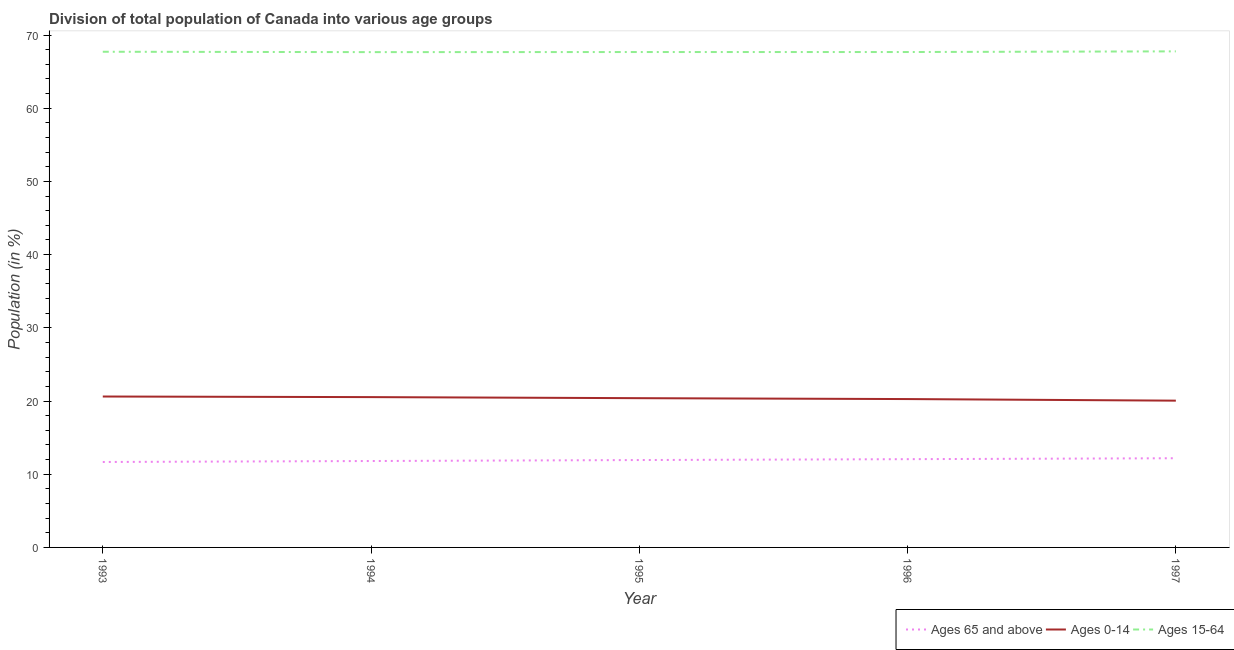How many different coloured lines are there?
Offer a very short reply. 3. Does the line corresponding to percentage of population within the age-group 15-64 intersect with the line corresponding to percentage of population within the age-group of 65 and above?
Ensure brevity in your answer.  No. What is the percentage of population within the age-group 15-64 in 1993?
Make the answer very short. 67.71. Across all years, what is the maximum percentage of population within the age-group of 65 and above?
Your answer should be very brief. 12.18. Across all years, what is the minimum percentage of population within the age-group of 65 and above?
Give a very brief answer. 11.67. In which year was the percentage of population within the age-group of 65 and above maximum?
Keep it short and to the point. 1997. What is the total percentage of population within the age-group 15-64 in the graph?
Your answer should be very brief. 338.49. What is the difference between the percentage of population within the age-group 0-14 in 1994 and that in 1995?
Your answer should be compact. 0.15. What is the difference between the percentage of population within the age-group 15-64 in 1997 and the percentage of population within the age-group 0-14 in 1993?
Ensure brevity in your answer.  47.15. What is the average percentage of population within the age-group 15-64 per year?
Give a very brief answer. 67.7. In the year 1994, what is the difference between the percentage of population within the age-group 15-64 and percentage of population within the age-group of 65 and above?
Make the answer very short. 55.86. What is the ratio of the percentage of population within the age-group 0-14 in 1993 to that in 1994?
Provide a succinct answer. 1. Is the percentage of population within the age-group 0-14 in 1995 less than that in 1996?
Offer a terse response. No. Is the difference between the percentage of population within the age-group 0-14 in 1994 and 1996 greater than the difference between the percentage of population within the age-group 15-64 in 1994 and 1996?
Give a very brief answer. Yes. What is the difference between the highest and the second highest percentage of population within the age-group 15-64?
Offer a very short reply. 0.05. What is the difference between the highest and the lowest percentage of population within the age-group of 65 and above?
Your answer should be very brief. 0.51. In how many years, is the percentage of population within the age-group 15-64 greater than the average percentage of population within the age-group 15-64 taken over all years?
Offer a very short reply. 2. Is the sum of the percentage of population within the age-group 0-14 in 1993 and 1994 greater than the maximum percentage of population within the age-group of 65 and above across all years?
Give a very brief answer. Yes. Is it the case that in every year, the sum of the percentage of population within the age-group of 65 and above and percentage of population within the age-group 0-14 is greater than the percentage of population within the age-group 15-64?
Keep it short and to the point. No. Does the percentage of population within the age-group 0-14 monotonically increase over the years?
Offer a very short reply. No. What is the difference between two consecutive major ticks on the Y-axis?
Make the answer very short. 10. Are the values on the major ticks of Y-axis written in scientific E-notation?
Make the answer very short. No. Does the graph contain any zero values?
Give a very brief answer. No. What is the title of the graph?
Your answer should be very brief. Division of total population of Canada into various age groups
. Does "Communicable diseases" appear as one of the legend labels in the graph?
Provide a short and direct response. No. What is the Population (in %) of Ages 65 and above in 1993?
Your answer should be compact. 11.67. What is the Population (in %) in Ages 0-14 in 1993?
Make the answer very short. 20.62. What is the Population (in %) in Ages 15-64 in 1993?
Your answer should be compact. 67.71. What is the Population (in %) of Ages 65 and above in 1994?
Your response must be concise. 11.8. What is the Population (in %) of Ages 0-14 in 1994?
Make the answer very short. 20.53. What is the Population (in %) of Ages 15-64 in 1994?
Keep it short and to the point. 67.66. What is the Population (in %) in Ages 65 and above in 1995?
Your answer should be very brief. 11.94. What is the Population (in %) in Ages 0-14 in 1995?
Your answer should be very brief. 20.39. What is the Population (in %) in Ages 15-64 in 1995?
Your answer should be very brief. 67.67. What is the Population (in %) of Ages 65 and above in 1996?
Offer a terse response. 12.06. What is the Population (in %) of Ages 0-14 in 1996?
Offer a very short reply. 20.27. What is the Population (in %) in Ages 15-64 in 1996?
Offer a very short reply. 67.67. What is the Population (in %) of Ages 65 and above in 1997?
Your answer should be very brief. 12.18. What is the Population (in %) of Ages 0-14 in 1997?
Make the answer very short. 20.05. What is the Population (in %) in Ages 15-64 in 1997?
Give a very brief answer. 67.77. Across all years, what is the maximum Population (in %) in Ages 65 and above?
Your answer should be very brief. 12.18. Across all years, what is the maximum Population (in %) of Ages 0-14?
Give a very brief answer. 20.62. Across all years, what is the maximum Population (in %) of Ages 15-64?
Provide a succinct answer. 67.77. Across all years, what is the minimum Population (in %) of Ages 65 and above?
Keep it short and to the point. 11.67. Across all years, what is the minimum Population (in %) of Ages 0-14?
Your answer should be very brief. 20.05. Across all years, what is the minimum Population (in %) in Ages 15-64?
Keep it short and to the point. 67.66. What is the total Population (in %) of Ages 65 and above in the graph?
Your answer should be very brief. 59.65. What is the total Population (in %) of Ages 0-14 in the graph?
Provide a short and direct response. 101.86. What is the total Population (in %) of Ages 15-64 in the graph?
Your answer should be very brief. 338.49. What is the difference between the Population (in %) in Ages 65 and above in 1993 and that in 1994?
Your response must be concise. -0.13. What is the difference between the Population (in %) of Ages 0-14 in 1993 and that in 1994?
Offer a terse response. 0.08. What is the difference between the Population (in %) in Ages 15-64 in 1993 and that in 1994?
Offer a terse response. 0.05. What is the difference between the Population (in %) of Ages 65 and above in 1993 and that in 1995?
Ensure brevity in your answer.  -0.27. What is the difference between the Population (in %) in Ages 0-14 in 1993 and that in 1995?
Your answer should be compact. 0.23. What is the difference between the Population (in %) of Ages 15-64 in 1993 and that in 1995?
Offer a terse response. 0.04. What is the difference between the Population (in %) of Ages 65 and above in 1993 and that in 1996?
Your answer should be very brief. -0.39. What is the difference between the Population (in %) in Ages 0-14 in 1993 and that in 1996?
Your response must be concise. 0.35. What is the difference between the Population (in %) in Ages 15-64 in 1993 and that in 1996?
Your answer should be compact. 0.04. What is the difference between the Population (in %) in Ages 65 and above in 1993 and that in 1997?
Ensure brevity in your answer.  -0.51. What is the difference between the Population (in %) of Ages 0-14 in 1993 and that in 1997?
Keep it short and to the point. 0.57. What is the difference between the Population (in %) in Ages 15-64 in 1993 and that in 1997?
Provide a succinct answer. -0.05. What is the difference between the Population (in %) of Ages 65 and above in 1994 and that in 1995?
Ensure brevity in your answer.  -0.13. What is the difference between the Population (in %) of Ages 0-14 in 1994 and that in 1995?
Keep it short and to the point. 0.15. What is the difference between the Population (in %) in Ages 15-64 in 1994 and that in 1995?
Keep it short and to the point. -0.01. What is the difference between the Population (in %) of Ages 65 and above in 1994 and that in 1996?
Make the answer very short. -0.25. What is the difference between the Population (in %) in Ages 0-14 in 1994 and that in 1996?
Your answer should be compact. 0.27. What is the difference between the Population (in %) in Ages 15-64 in 1994 and that in 1996?
Your answer should be compact. -0.01. What is the difference between the Population (in %) of Ages 65 and above in 1994 and that in 1997?
Make the answer very short. -0.38. What is the difference between the Population (in %) of Ages 0-14 in 1994 and that in 1997?
Offer a terse response. 0.48. What is the difference between the Population (in %) of Ages 15-64 in 1994 and that in 1997?
Make the answer very short. -0.1. What is the difference between the Population (in %) of Ages 65 and above in 1995 and that in 1996?
Ensure brevity in your answer.  -0.12. What is the difference between the Population (in %) of Ages 0-14 in 1995 and that in 1996?
Give a very brief answer. 0.12. What is the difference between the Population (in %) of Ages 15-64 in 1995 and that in 1996?
Offer a very short reply. -0. What is the difference between the Population (in %) in Ages 65 and above in 1995 and that in 1997?
Offer a very short reply. -0.25. What is the difference between the Population (in %) in Ages 0-14 in 1995 and that in 1997?
Keep it short and to the point. 0.34. What is the difference between the Population (in %) of Ages 15-64 in 1995 and that in 1997?
Your answer should be compact. -0.09. What is the difference between the Population (in %) in Ages 65 and above in 1996 and that in 1997?
Your answer should be compact. -0.13. What is the difference between the Population (in %) of Ages 0-14 in 1996 and that in 1997?
Provide a succinct answer. 0.22. What is the difference between the Population (in %) in Ages 15-64 in 1996 and that in 1997?
Your response must be concise. -0.09. What is the difference between the Population (in %) of Ages 65 and above in 1993 and the Population (in %) of Ages 0-14 in 1994?
Your answer should be compact. -8.86. What is the difference between the Population (in %) in Ages 65 and above in 1993 and the Population (in %) in Ages 15-64 in 1994?
Keep it short and to the point. -55.99. What is the difference between the Population (in %) in Ages 0-14 in 1993 and the Population (in %) in Ages 15-64 in 1994?
Your response must be concise. -47.05. What is the difference between the Population (in %) of Ages 65 and above in 1993 and the Population (in %) of Ages 0-14 in 1995?
Give a very brief answer. -8.72. What is the difference between the Population (in %) of Ages 65 and above in 1993 and the Population (in %) of Ages 15-64 in 1995?
Provide a succinct answer. -56. What is the difference between the Population (in %) of Ages 0-14 in 1993 and the Population (in %) of Ages 15-64 in 1995?
Offer a very short reply. -47.06. What is the difference between the Population (in %) in Ages 65 and above in 1993 and the Population (in %) in Ages 0-14 in 1996?
Provide a short and direct response. -8.6. What is the difference between the Population (in %) in Ages 65 and above in 1993 and the Population (in %) in Ages 15-64 in 1996?
Offer a very short reply. -56. What is the difference between the Population (in %) of Ages 0-14 in 1993 and the Population (in %) of Ages 15-64 in 1996?
Keep it short and to the point. -47.06. What is the difference between the Population (in %) in Ages 65 and above in 1993 and the Population (in %) in Ages 0-14 in 1997?
Ensure brevity in your answer.  -8.38. What is the difference between the Population (in %) of Ages 65 and above in 1993 and the Population (in %) of Ages 15-64 in 1997?
Provide a short and direct response. -56.09. What is the difference between the Population (in %) of Ages 0-14 in 1993 and the Population (in %) of Ages 15-64 in 1997?
Offer a very short reply. -47.15. What is the difference between the Population (in %) of Ages 65 and above in 1994 and the Population (in %) of Ages 0-14 in 1995?
Your answer should be compact. -8.59. What is the difference between the Population (in %) of Ages 65 and above in 1994 and the Population (in %) of Ages 15-64 in 1995?
Make the answer very short. -55.87. What is the difference between the Population (in %) in Ages 0-14 in 1994 and the Population (in %) in Ages 15-64 in 1995?
Offer a terse response. -47.14. What is the difference between the Population (in %) in Ages 65 and above in 1994 and the Population (in %) in Ages 0-14 in 1996?
Your answer should be very brief. -8.46. What is the difference between the Population (in %) in Ages 65 and above in 1994 and the Population (in %) in Ages 15-64 in 1996?
Make the answer very short. -55.87. What is the difference between the Population (in %) in Ages 0-14 in 1994 and the Population (in %) in Ages 15-64 in 1996?
Provide a short and direct response. -47.14. What is the difference between the Population (in %) of Ages 65 and above in 1994 and the Population (in %) of Ages 0-14 in 1997?
Give a very brief answer. -8.25. What is the difference between the Population (in %) in Ages 65 and above in 1994 and the Population (in %) in Ages 15-64 in 1997?
Provide a short and direct response. -55.96. What is the difference between the Population (in %) in Ages 0-14 in 1994 and the Population (in %) in Ages 15-64 in 1997?
Provide a short and direct response. -47.23. What is the difference between the Population (in %) of Ages 65 and above in 1995 and the Population (in %) of Ages 0-14 in 1996?
Provide a succinct answer. -8.33. What is the difference between the Population (in %) in Ages 65 and above in 1995 and the Population (in %) in Ages 15-64 in 1996?
Make the answer very short. -55.74. What is the difference between the Population (in %) in Ages 0-14 in 1995 and the Population (in %) in Ages 15-64 in 1996?
Make the answer very short. -47.29. What is the difference between the Population (in %) in Ages 65 and above in 1995 and the Population (in %) in Ages 0-14 in 1997?
Provide a short and direct response. -8.11. What is the difference between the Population (in %) of Ages 65 and above in 1995 and the Population (in %) of Ages 15-64 in 1997?
Provide a short and direct response. -55.83. What is the difference between the Population (in %) of Ages 0-14 in 1995 and the Population (in %) of Ages 15-64 in 1997?
Your answer should be compact. -47.38. What is the difference between the Population (in %) of Ages 65 and above in 1996 and the Population (in %) of Ages 0-14 in 1997?
Keep it short and to the point. -7.99. What is the difference between the Population (in %) of Ages 65 and above in 1996 and the Population (in %) of Ages 15-64 in 1997?
Make the answer very short. -55.71. What is the difference between the Population (in %) in Ages 0-14 in 1996 and the Population (in %) in Ages 15-64 in 1997?
Provide a succinct answer. -47.5. What is the average Population (in %) in Ages 65 and above per year?
Your answer should be compact. 11.93. What is the average Population (in %) in Ages 0-14 per year?
Keep it short and to the point. 20.37. What is the average Population (in %) in Ages 15-64 per year?
Your answer should be very brief. 67.7. In the year 1993, what is the difference between the Population (in %) in Ages 65 and above and Population (in %) in Ages 0-14?
Give a very brief answer. -8.94. In the year 1993, what is the difference between the Population (in %) of Ages 65 and above and Population (in %) of Ages 15-64?
Provide a succinct answer. -56.04. In the year 1993, what is the difference between the Population (in %) of Ages 0-14 and Population (in %) of Ages 15-64?
Your response must be concise. -47.1. In the year 1994, what is the difference between the Population (in %) in Ages 65 and above and Population (in %) in Ages 0-14?
Your response must be concise. -8.73. In the year 1994, what is the difference between the Population (in %) of Ages 65 and above and Population (in %) of Ages 15-64?
Your response must be concise. -55.86. In the year 1994, what is the difference between the Population (in %) of Ages 0-14 and Population (in %) of Ages 15-64?
Offer a very short reply. -47.13. In the year 1995, what is the difference between the Population (in %) of Ages 65 and above and Population (in %) of Ages 0-14?
Offer a very short reply. -8.45. In the year 1995, what is the difference between the Population (in %) of Ages 65 and above and Population (in %) of Ages 15-64?
Make the answer very short. -55.74. In the year 1995, what is the difference between the Population (in %) in Ages 0-14 and Population (in %) in Ages 15-64?
Your response must be concise. -47.28. In the year 1996, what is the difference between the Population (in %) of Ages 65 and above and Population (in %) of Ages 0-14?
Make the answer very short. -8.21. In the year 1996, what is the difference between the Population (in %) in Ages 65 and above and Population (in %) in Ages 15-64?
Keep it short and to the point. -55.62. In the year 1996, what is the difference between the Population (in %) in Ages 0-14 and Population (in %) in Ages 15-64?
Keep it short and to the point. -47.41. In the year 1997, what is the difference between the Population (in %) of Ages 65 and above and Population (in %) of Ages 0-14?
Make the answer very short. -7.87. In the year 1997, what is the difference between the Population (in %) in Ages 65 and above and Population (in %) in Ages 15-64?
Your answer should be compact. -55.58. In the year 1997, what is the difference between the Population (in %) in Ages 0-14 and Population (in %) in Ages 15-64?
Ensure brevity in your answer.  -47.72. What is the ratio of the Population (in %) of Ages 65 and above in 1993 to that in 1994?
Make the answer very short. 0.99. What is the ratio of the Population (in %) in Ages 0-14 in 1993 to that in 1994?
Make the answer very short. 1. What is the ratio of the Population (in %) of Ages 65 and above in 1993 to that in 1995?
Keep it short and to the point. 0.98. What is the ratio of the Population (in %) in Ages 0-14 in 1993 to that in 1995?
Give a very brief answer. 1.01. What is the ratio of the Population (in %) in Ages 65 and above in 1993 to that in 1996?
Ensure brevity in your answer.  0.97. What is the ratio of the Population (in %) of Ages 0-14 in 1993 to that in 1996?
Ensure brevity in your answer.  1.02. What is the ratio of the Population (in %) of Ages 65 and above in 1993 to that in 1997?
Make the answer very short. 0.96. What is the ratio of the Population (in %) of Ages 0-14 in 1993 to that in 1997?
Provide a short and direct response. 1.03. What is the ratio of the Population (in %) of Ages 15-64 in 1993 to that in 1997?
Offer a very short reply. 1. What is the ratio of the Population (in %) of Ages 65 and above in 1994 to that in 1995?
Make the answer very short. 0.99. What is the ratio of the Population (in %) in Ages 0-14 in 1994 to that in 1995?
Ensure brevity in your answer.  1.01. What is the ratio of the Population (in %) of Ages 65 and above in 1994 to that in 1996?
Offer a terse response. 0.98. What is the ratio of the Population (in %) in Ages 0-14 in 1994 to that in 1996?
Give a very brief answer. 1.01. What is the ratio of the Population (in %) in Ages 65 and above in 1994 to that in 1997?
Your response must be concise. 0.97. What is the ratio of the Population (in %) of Ages 0-14 in 1994 to that in 1997?
Your response must be concise. 1.02. What is the ratio of the Population (in %) of Ages 65 and above in 1995 to that in 1996?
Ensure brevity in your answer.  0.99. What is the ratio of the Population (in %) of Ages 0-14 in 1995 to that in 1996?
Ensure brevity in your answer.  1.01. What is the ratio of the Population (in %) in Ages 15-64 in 1995 to that in 1996?
Your answer should be compact. 1. What is the ratio of the Population (in %) in Ages 65 and above in 1995 to that in 1997?
Provide a short and direct response. 0.98. What is the ratio of the Population (in %) in Ages 0-14 in 1995 to that in 1997?
Offer a terse response. 1.02. What is the ratio of the Population (in %) in Ages 15-64 in 1995 to that in 1997?
Your answer should be compact. 1. What is the ratio of the Population (in %) in Ages 65 and above in 1996 to that in 1997?
Offer a terse response. 0.99. What is the ratio of the Population (in %) of Ages 0-14 in 1996 to that in 1997?
Your answer should be very brief. 1.01. What is the ratio of the Population (in %) in Ages 15-64 in 1996 to that in 1997?
Offer a very short reply. 1. What is the difference between the highest and the second highest Population (in %) of Ages 65 and above?
Give a very brief answer. 0.13. What is the difference between the highest and the second highest Population (in %) in Ages 0-14?
Ensure brevity in your answer.  0.08. What is the difference between the highest and the second highest Population (in %) of Ages 15-64?
Give a very brief answer. 0.05. What is the difference between the highest and the lowest Population (in %) in Ages 65 and above?
Your response must be concise. 0.51. What is the difference between the highest and the lowest Population (in %) in Ages 0-14?
Provide a short and direct response. 0.57. What is the difference between the highest and the lowest Population (in %) of Ages 15-64?
Your answer should be very brief. 0.1. 